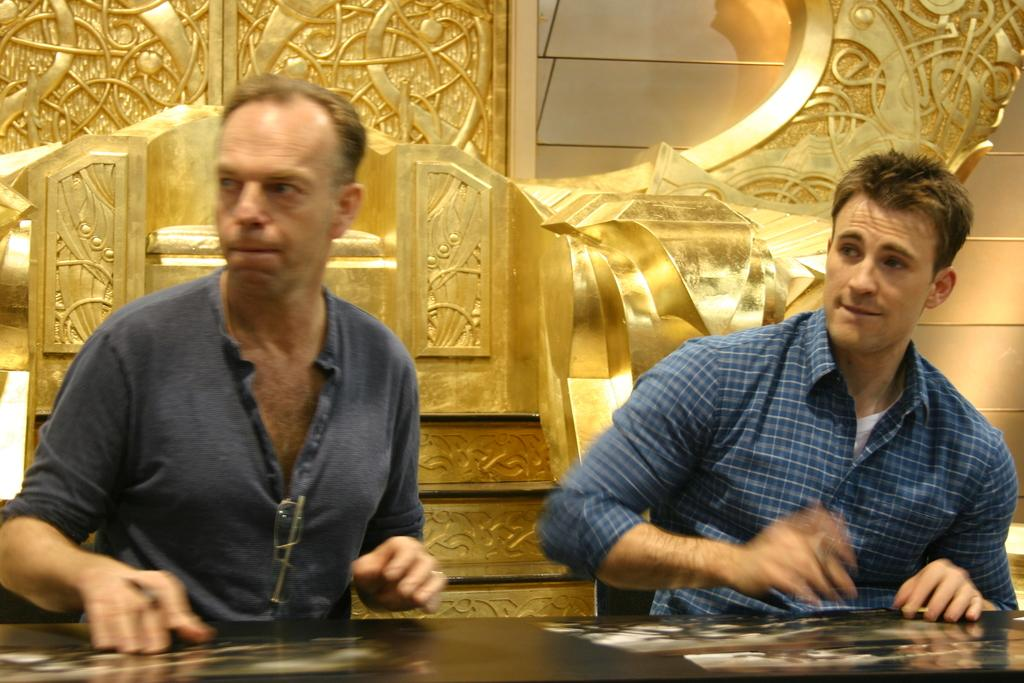How many people are in the image? There are two persons in the image. What are the persons doing in the image? The persons are sitting at a table. What objects can be seen on the table? There are photographs on the table. What can be seen in the background of the image? There is a wall and architecture visible in the background of the image. What decision did the achiever make in the image? There is no mention of an achiever or any decision-making in the image. The image only shows two persons sitting at a table with photographs on it, and a wall with architecture visible in the background. 